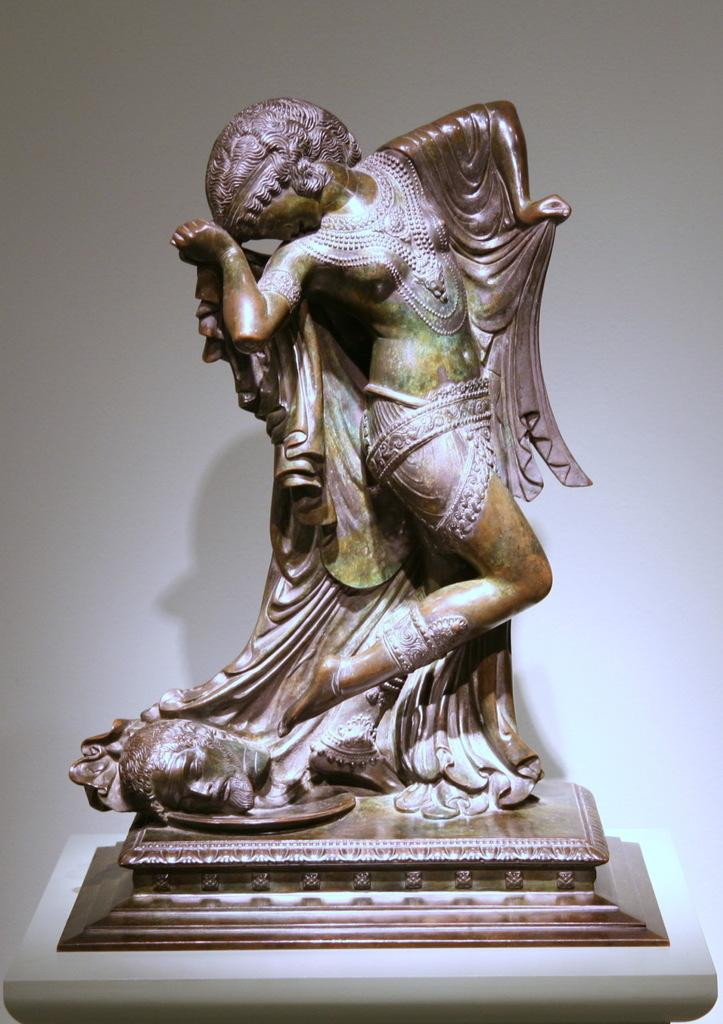What is the main subject of the image? There is an art statue in the image. Where is the art statue located? The art statue is present on a table. What type of education can be seen being provided on the sidewalk in the image? There is no mention of education or a sidewalk in the image; it features an art statue on a table. 